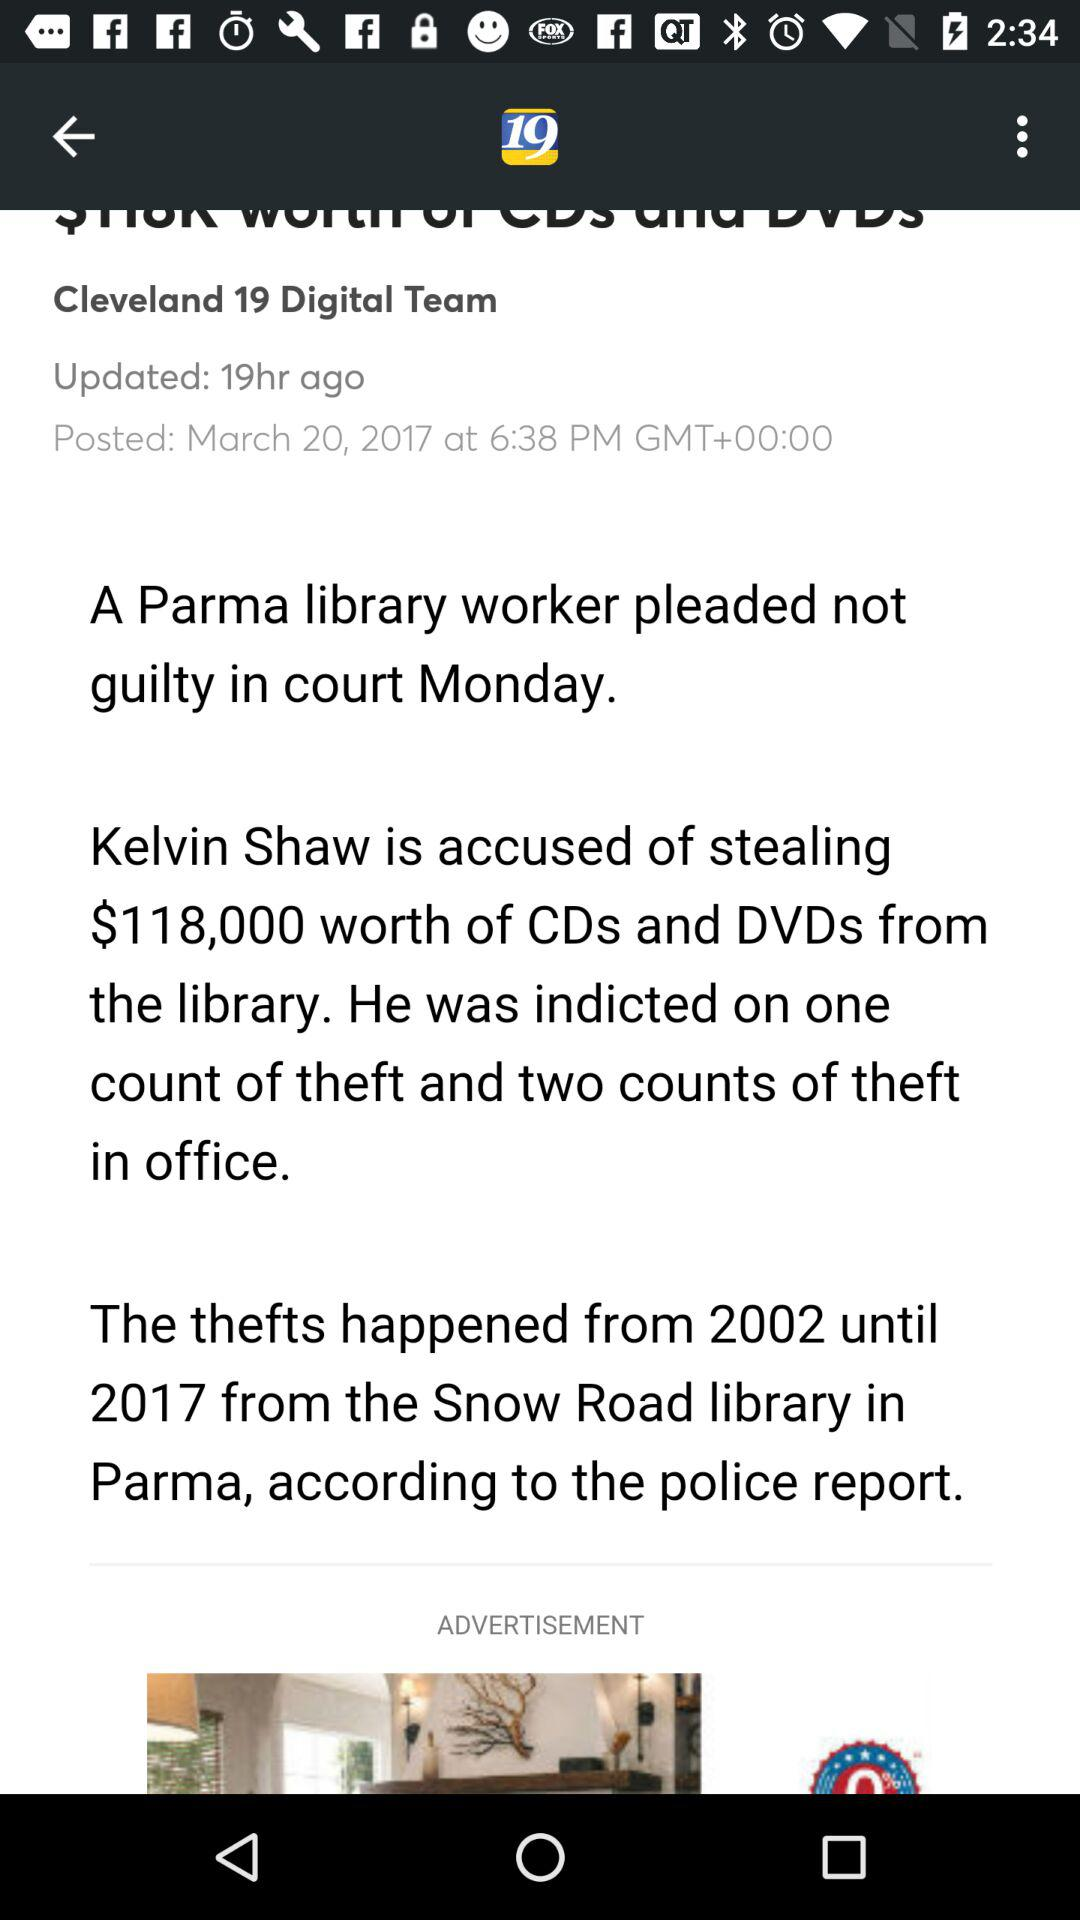In which year did the theft happen? The theft happened from 2002 until 2017. 